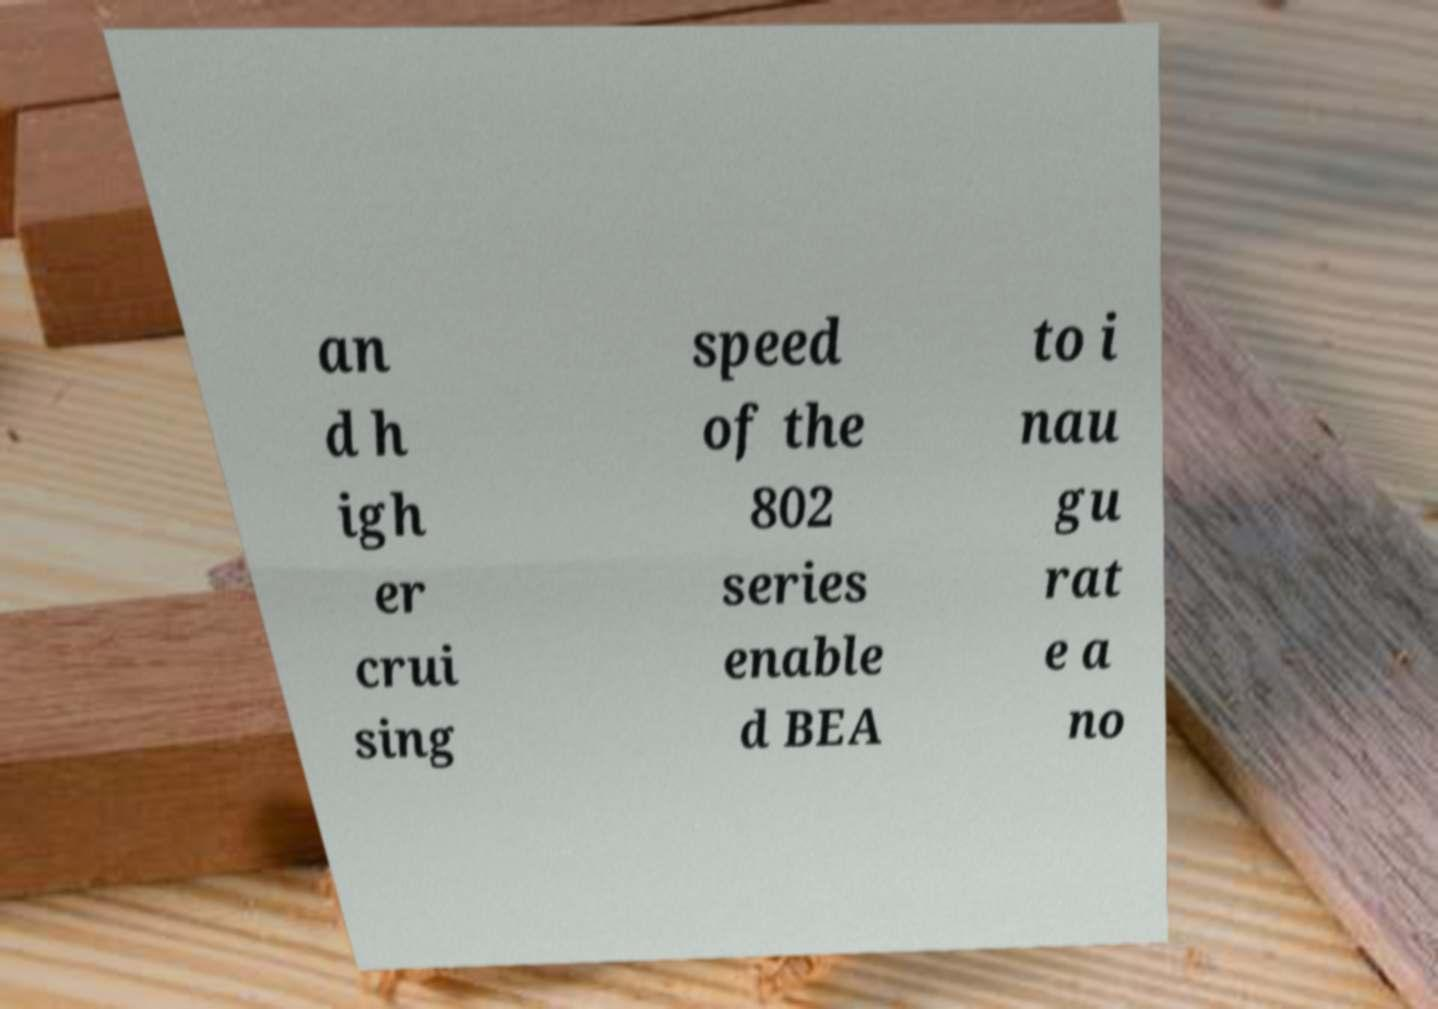Could you assist in decoding the text presented in this image and type it out clearly? an d h igh er crui sing speed of the 802 series enable d BEA to i nau gu rat e a no 